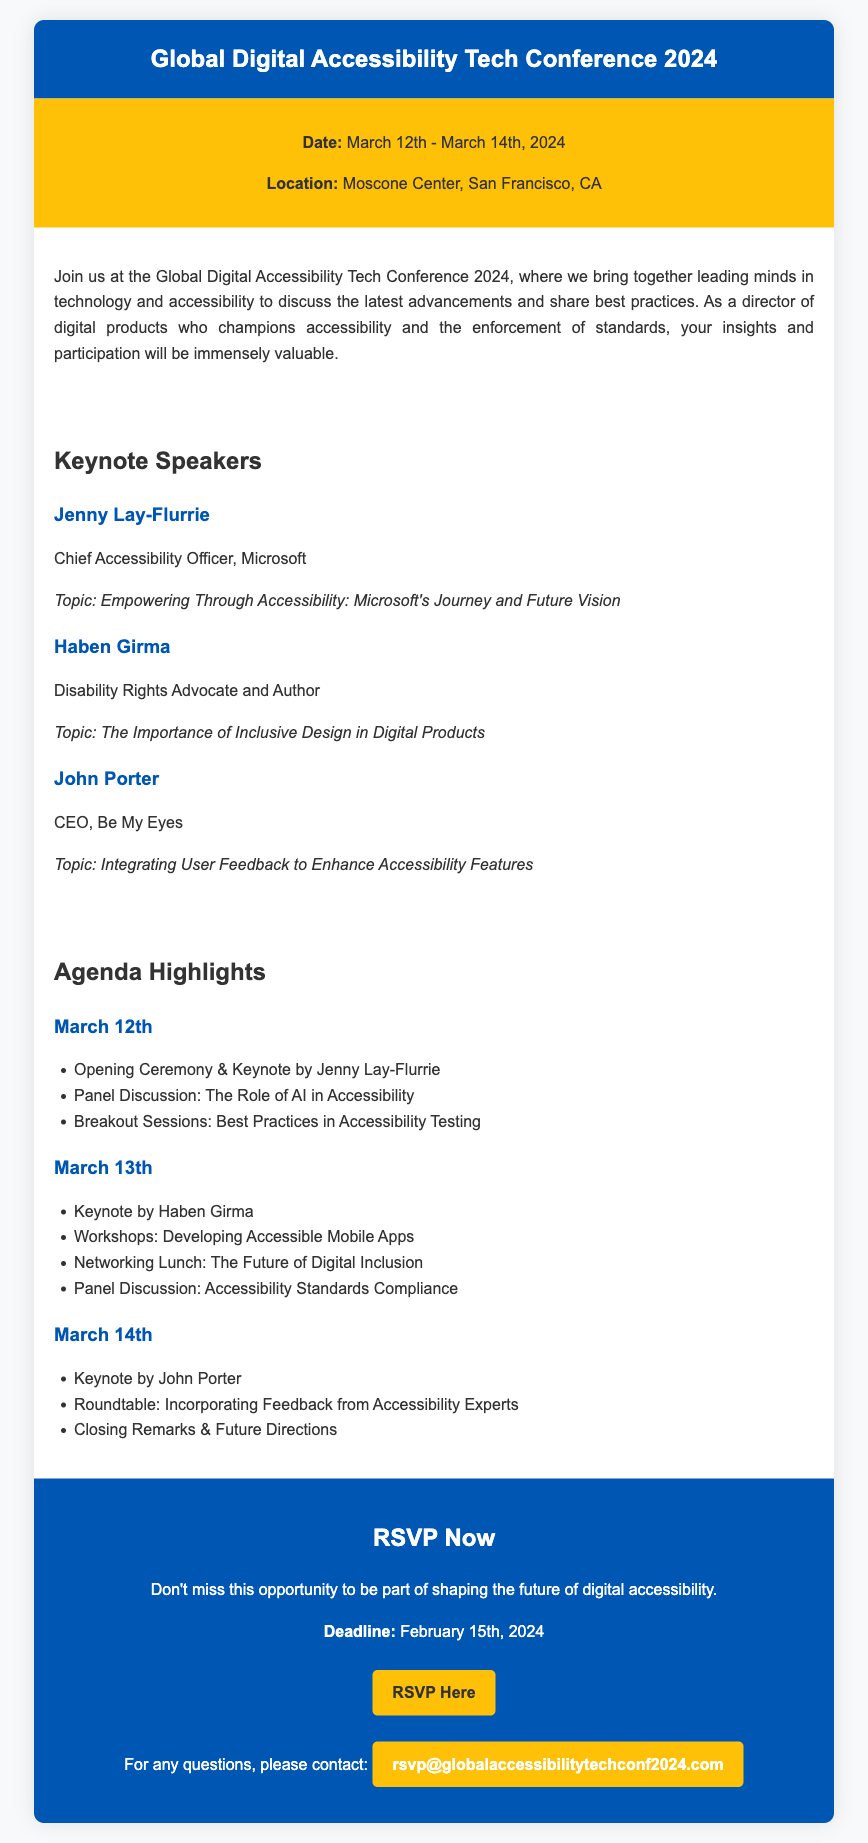What are the dates of the conference? The dates of the conference are mentioned in the event details section of the document.
Answer: March 12th - March 14th, 2024 Who is the Chief Accessibility Officer at Microsoft? This information can be found under the keynote speakers section, where each speaker's title and name are listed.
Answer: Jenny Lay-Flurrie What is the location of the conference? The location is provided in the event details.
Answer: Moscone Center, San Francisco, CA What is the RSVP deadline? The RSVP deadline is stated in the RSVP section of the document.
Answer: February 15th, 2024 What is the topic of Haben Girma's keynote? The topic can be found alongside each speaker's name and title in the speakers section.
Answer: The Importance of Inclusive Design in Digital Products How many days does the conference last? The duration of the conference can be inferred from the date range given in the information.
Answer: Three days What is one highlight of the agenda on March 13th? The highlights for March 13th are listed in the agenda section of the document.
Answer: Workshops: Developing Accessible Mobile Apps What theme do the keynote speakers address? The document suggests that the speakers are discussing various topics related to accessibility and design.
Answer: Accessibility What type of event is this card for? The document type indicates the purpose and nature of the content presented.
Answer: Conference 